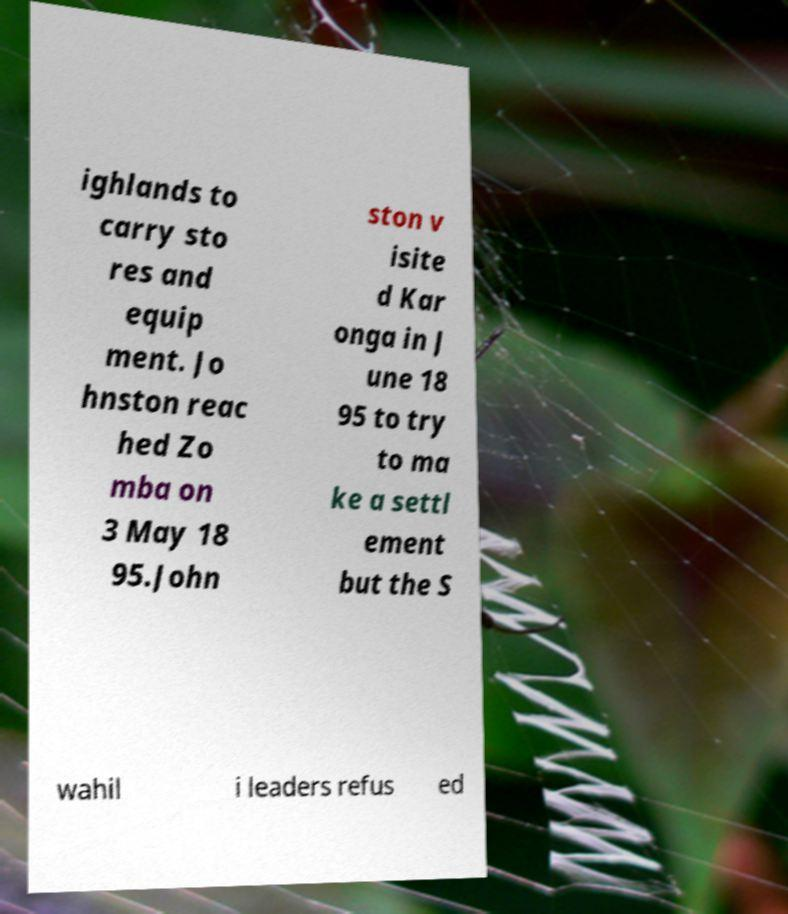Could you extract and type out the text from this image? ighlands to carry sto res and equip ment. Jo hnston reac hed Zo mba on 3 May 18 95.John ston v isite d Kar onga in J une 18 95 to try to ma ke a settl ement but the S wahil i leaders refus ed 